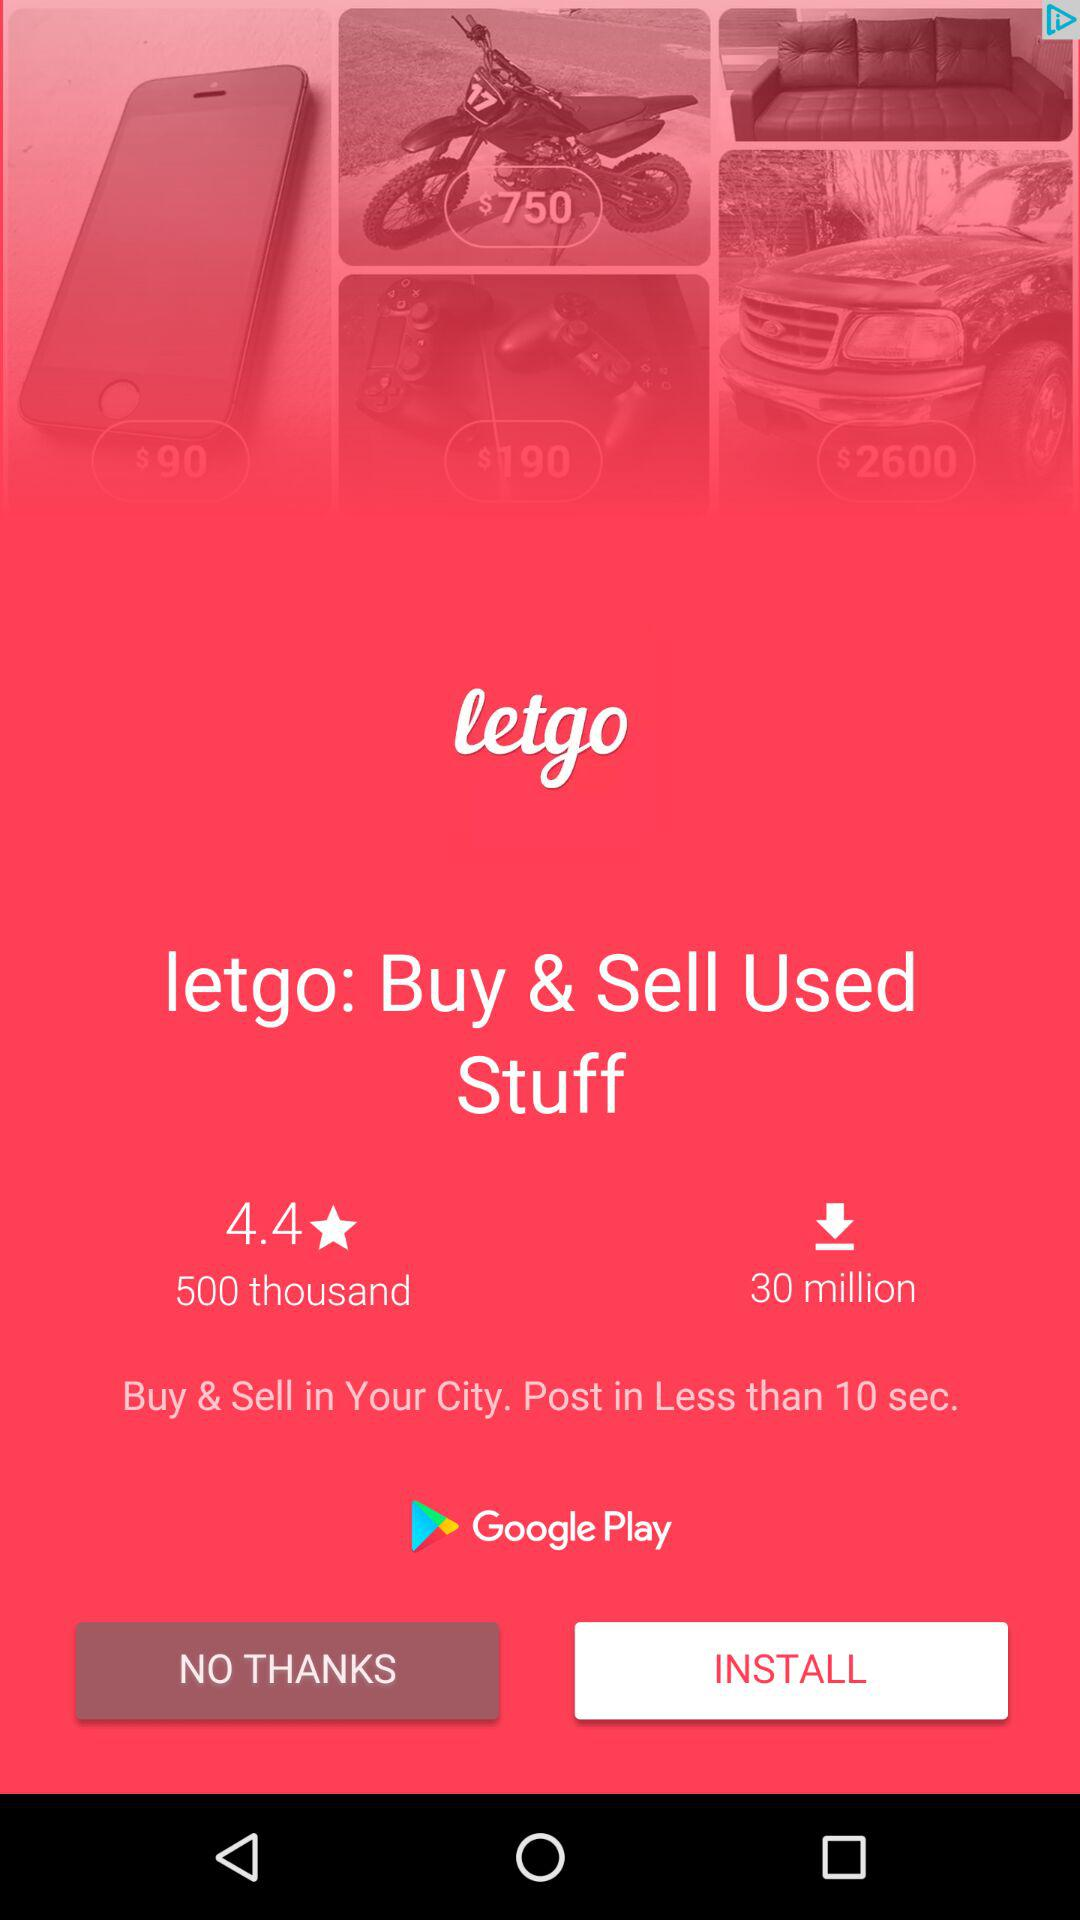How many more downloads does letgo have than 500 thousand?
Answer the question using a single word or phrase. 29.5 million 